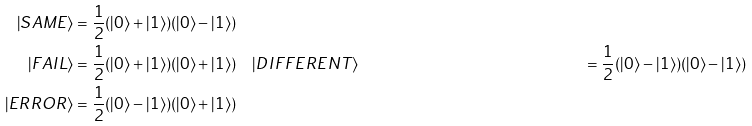<formula> <loc_0><loc_0><loc_500><loc_500>| S A M E \rangle & = { \frac { 1 } { 2 } } ( | 0 \rangle + | 1 \rangle ) ( | 0 \rangle - | 1 \rangle ) \\ | F A I L \rangle & = { \frac { 1 } { 2 } } ( | 0 \rangle + | 1 \rangle ) ( | 0 \rangle + | 1 \rangle ) \quad | D I F F E R E N T \rangle & = { \frac { 1 } { 2 } } ( | 0 \rangle - | 1 \rangle ) ( | 0 \rangle - | 1 \rangle ) \\ | E R R O R \rangle & = { \frac { 1 } { 2 } } ( | 0 \rangle - | 1 \rangle ) ( | 0 \rangle + | 1 \rangle )</formula> 